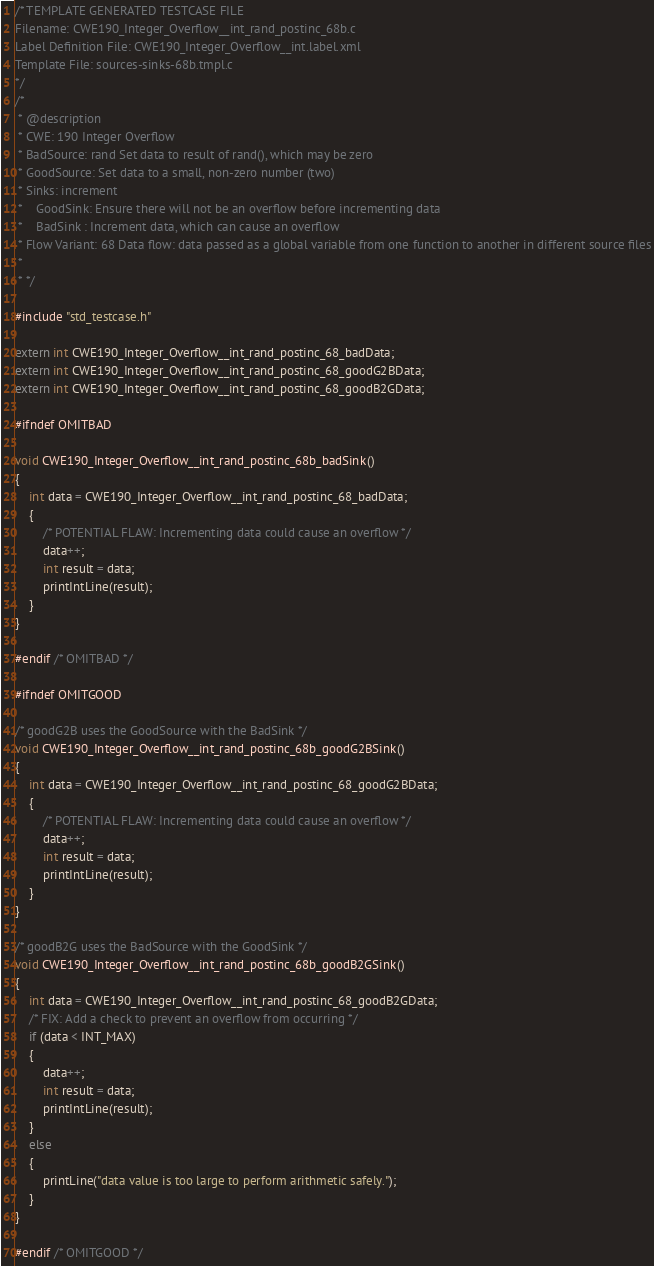Convert code to text. <code><loc_0><loc_0><loc_500><loc_500><_C_>/* TEMPLATE GENERATED TESTCASE FILE
Filename: CWE190_Integer_Overflow__int_rand_postinc_68b.c
Label Definition File: CWE190_Integer_Overflow__int.label.xml
Template File: sources-sinks-68b.tmpl.c
*/
/*
 * @description
 * CWE: 190 Integer Overflow
 * BadSource: rand Set data to result of rand(), which may be zero
 * GoodSource: Set data to a small, non-zero number (two)
 * Sinks: increment
 *    GoodSink: Ensure there will not be an overflow before incrementing data
 *    BadSink : Increment data, which can cause an overflow
 * Flow Variant: 68 Data flow: data passed as a global variable from one function to another in different source files
 *
 * */

#include "std_testcase.h"

extern int CWE190_Integer_Overflow__int_rand_postinc_68_badData;
extern int CWE190_Integer_Overflow__int_rand_postinc_68_goodG2BData;
extern int CWE190_Integer_Overflow__int_rand_postinc_68_goodB2GData;

#ifndef OMITBAD

void CWE190_Integer_Overflow__int_rand_postinc_68b_badSink()
{
    int data = CWE190_Integer_Overflow__int_rand_postinc_68_badData;
    {
        /* POTENTIAL FLAW: Incrementing data could cause an overflow */
        data++;
        int result = data;
        printIntLine(result);
    }
}

#endif /* OMITBAD */

#ifndef OMITGOOD

/* goodG2B uses the GoodSource with the BadSink */
void CWE190_Integer_Overflow__int_rand_postinc_68b_goodG2BSink()
{
    int data = CWE190_Integer_Overflow__int_rand_postinc_68_goodG2BData;
    {
        /* POTENTIAL FLAW: Incrementing data could cause an overflow */
        data++;
        int result = data;
        printIntLine(result);
    }
}

/* goodB2G uses the BadSource with the GoodSink */
void CWE190_Integer_Overflow__int_rand_postinc_68b_goodB2GSink()
{
    int data = CWE190_Integer_Overflow__int_rand_postinc_68_goodB2GData;
    /* FIX: Add a check to prevent an overflow from occurring */
    if (data < INT_MAX)
    {
        data++;
        int result = data;
        printIntLine(result);
    }
    else
    {
        printLine("data value is too large to perform arithmetic safely.");
    }
}

#endif /* OMITGOOD */
</code> 